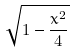Convert formula to latex. <formula><loc_0><loc_0><loc_500><loc_500>\sqrt { 1 - \frac { x ^ { 2 } } { 4 } }</formula> 